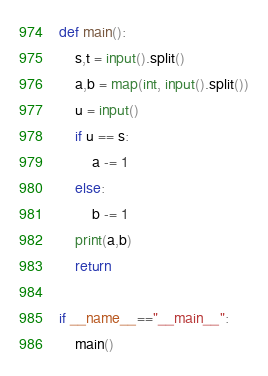<code> <loc_0><loc_0><loc_500><loc_500><_Python_>def main():
    s,t = input().split()
    a,b = map(int, input().split())
    u = input()
    if u == s:
        a -= 1
    else:
        b -= 1    
    print(a,b)
    return

if __name__=="__main__":
    main()</code> 